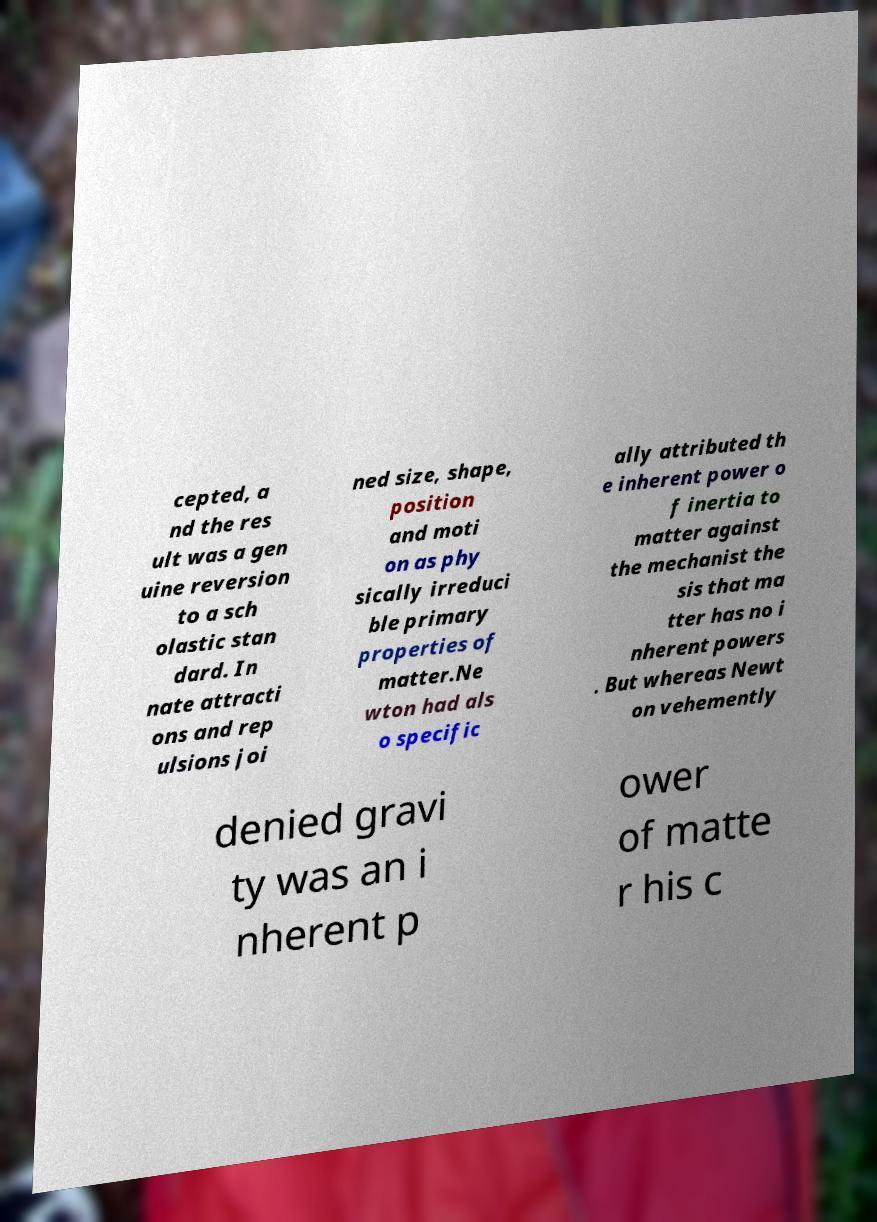Could you assist in decoding the text presented in this image and type it out clearly? cepted, a nd the res ult was a gen uine reversion to a sch olastic stan dard. In nate attracti ons and rep ulsions joi ned size, shape, position and moti on as phy sically irreduci ble primary properties of matter.Ne wton had als o specific ally attributed th e inherent power o f inertia to matter against the mechanist the sis that ma tter has no i nherent powers . But whereas Newt on vehemently denied gravi ty was an i nherent p ower of matte r his c 